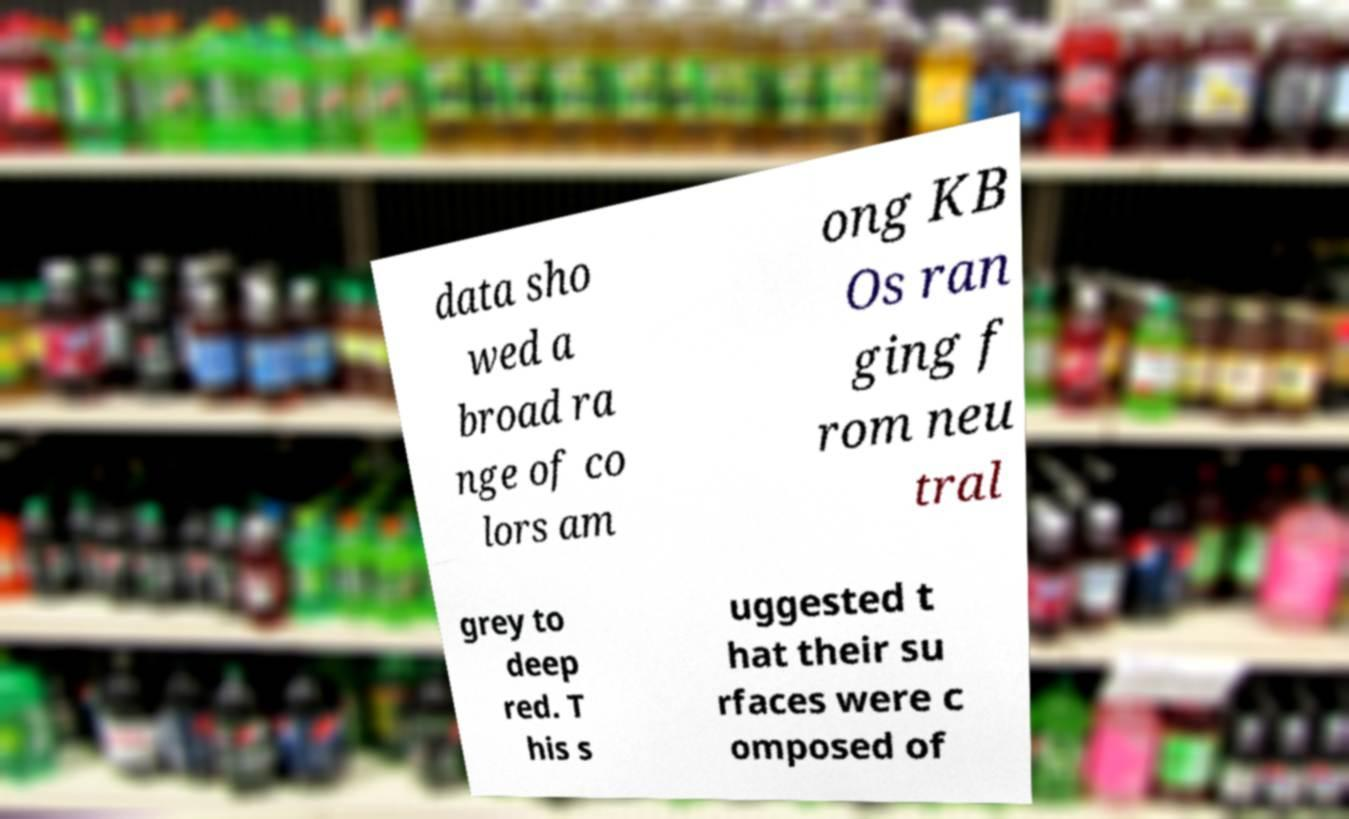For documentation purposes, I need the text within this image transcribed. Could you provide that? data sho wed a broad ra nge of co lors am ong KB Os ran ging f rom neu tral grey to deep red. T his s uggested t hat their su rfaces were c omposed of 